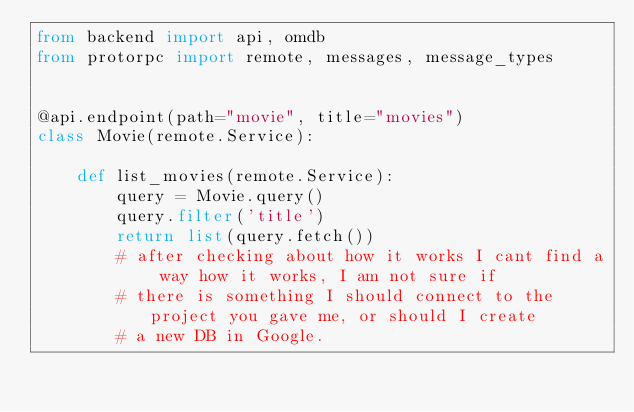<code> <loc_0><loc_0><loc_500><loc_500><_Python_>from backend import api, omdb
from protorpc import remote, messages, message_types


@api.endpoint(path="movie", title="movies")
class Movie(remote.Service):

    def list_movies(remote.Service):
        query = Movie.query()
        query.filter('title')
        return list(query.fetch())
        # after checking about how it works I cant find a way how it works, I am not sure if
        # there is something I should connect to the project you gave me, or should I create
        # a new DB in Google. 
</code> 